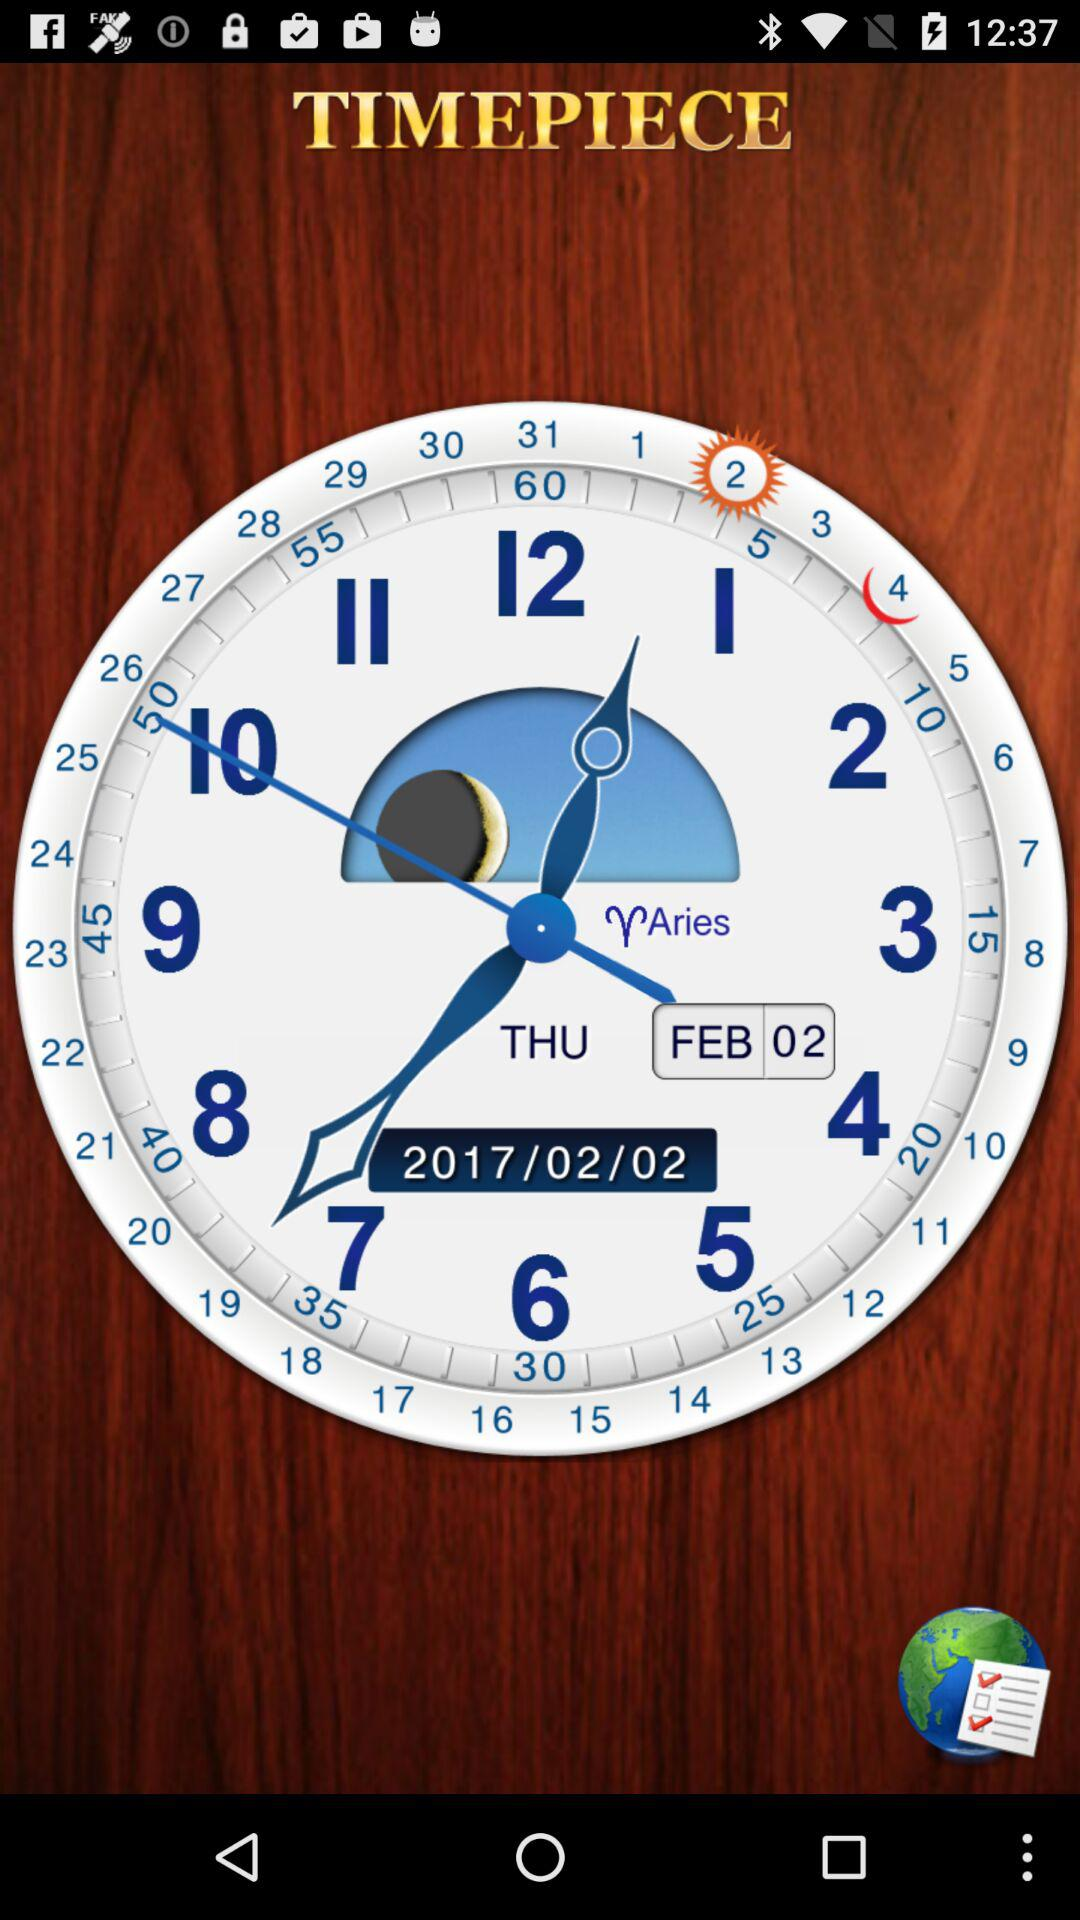What is the date on the timepiece? The date on the timepiece is Thursday, February 2, 2017. 